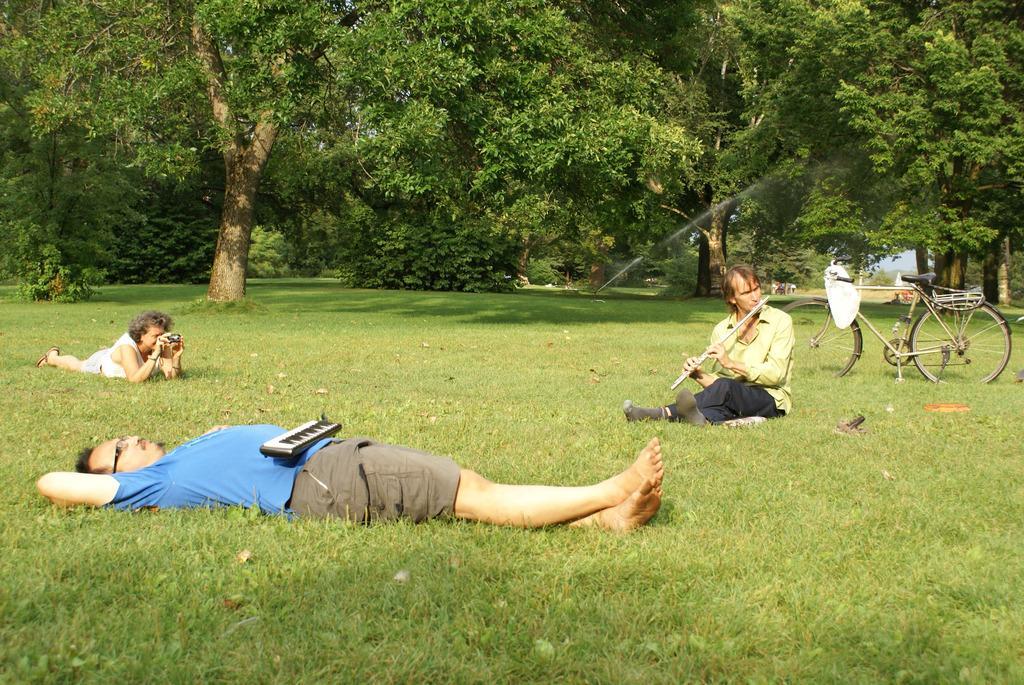Please provide a concise description of this image. In this picture, we see the man in blue T-shirt is lying on the grass. We see a musical instrument which looks like a keyboard is placed on him. At the bottom of the picture, we see the grass. The woman in white dress is lying on the grass and she is clicking photos on the camera. The man in green shirt is playing a musical instrument and he is sitting on the grass. Behind him, we see a bicycle. There are trees in the background. This picture might be clicked in the garden or in the park. 